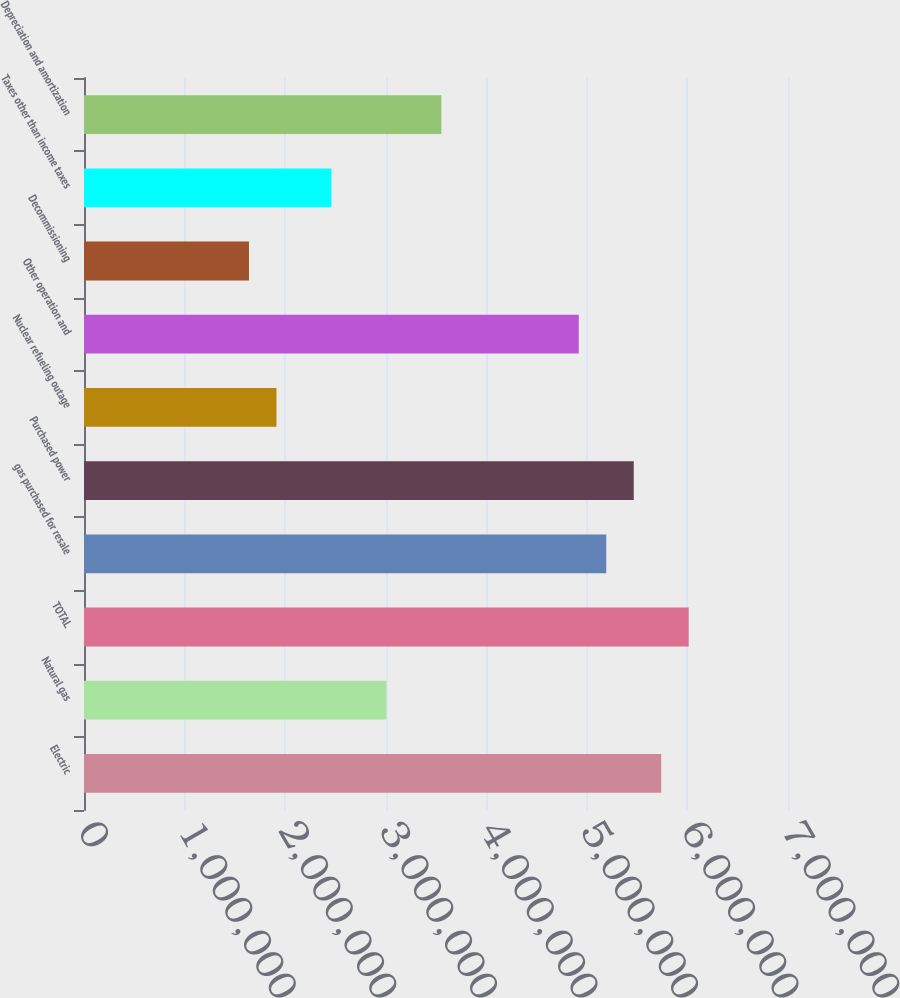Convert chart. <chart><loc_0><loc_0><loc_500><loc_500><bar_chart><fcel>Electric<fcel>Natural gas<fcel>TOTAL<fcel>gas purchased for resale<fcel>Purchased power<fcel>Nuclear refueling outage<fcel>Other operation and<fcel>Decommissioning<fcel>Taxes other than income taxes<fcel>Depreciation and amortization<nl><fcel>5.73932e+06<fcel>3.00663e+06<fcel>6.01259e+06<fcel>5.19278e+06<fcel>5.46605e+06<fcel>1.91356e+06<fcel>4.91951e+06<fcel>1.64029e+06<fcel>2.4601e+06<fcel>3.55317e+06<nl></chart> 